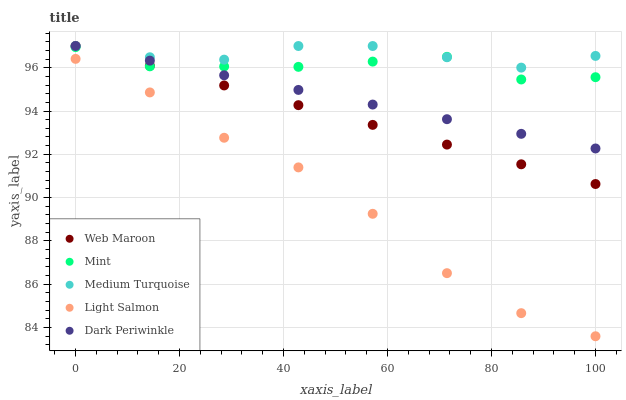Does Light Salmon have the minimum area under the curve?
Answer yes or no. Yes. Does Medium Turquoise have the maximum area under the curve?
Answer yes or no. Yes. Does Web Maroon have the minimum area under the curve?
Answer yes or no. No. Does Web Maroon have the maximum area under the curve?
Answer yes or no. No. Is Dark Periwinkle the smoothest?
Answer yes or no. Yes. Is Light Salmon the roughest?
Answer yes or no. Yes. Is Web Maroon the smoothest?
Answer yes or no. No. Is Web Maroon the roughest?
Answer yes or no. No. Does Light Salmon have the lowest value?
Answer yes or no. Yes. Does Web Maroon have the lowest value?
Answer yes or no. No. Does Medium Turquoise have the highest value?
Answer yes or no. Yes. Does Light Salmon have the highest value?
Answer yes or no. No. Is Light Salmon less than Dark Periwinkle?
Answer yes or no. Yes. Is Dark Periwinkle greater than Light Salmon?
Answer yes or no. Yes. Does Dark Periwinkle intersect Medium Turquoise?
Answer yes or no. Yes. Is Dark Periwinkle less than Medium Turquoise?
Answer yes or no. No. Is Dark Periwinkle greater than Medium Turquoise?
Answer yes or no. No. Does Light Salmon intersect Dark Periwinkle?
Answer yes or no. No. 